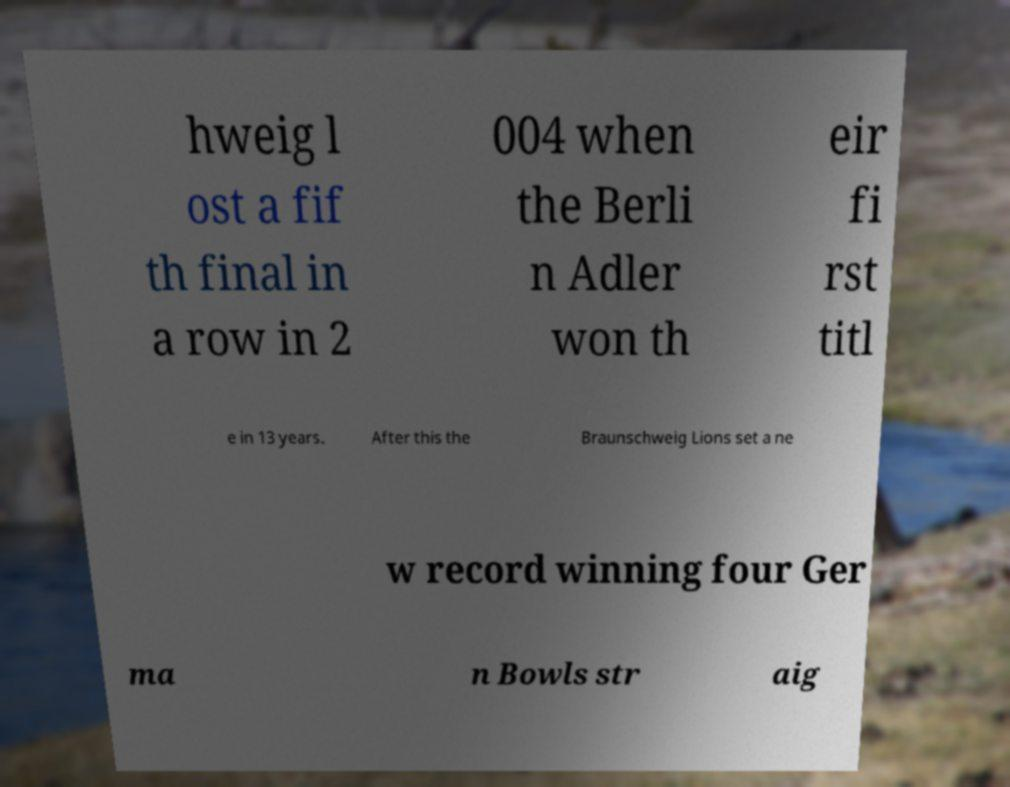Can you accurately transcribe the text from the provided image for me? hweig l ost a fif th final in a row in 2 004 when the Berli n Adler won th eir fi rst titl e in 13 years. After this the Braunschweig Lions set a ne w record winning four Ger ma n Bowls str aig 